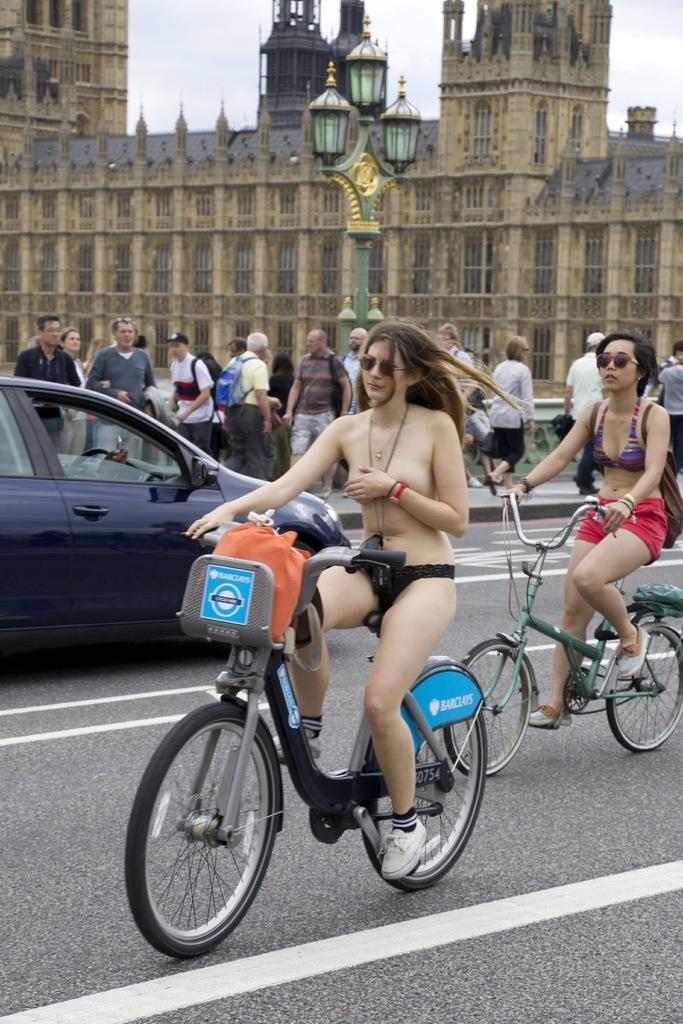In one or two sentences, can you explain what this image depicts? In this image two women are riding bicycle. On the left there is a car. There are few people walking by the street side way. There is street light. In the background there is building. 